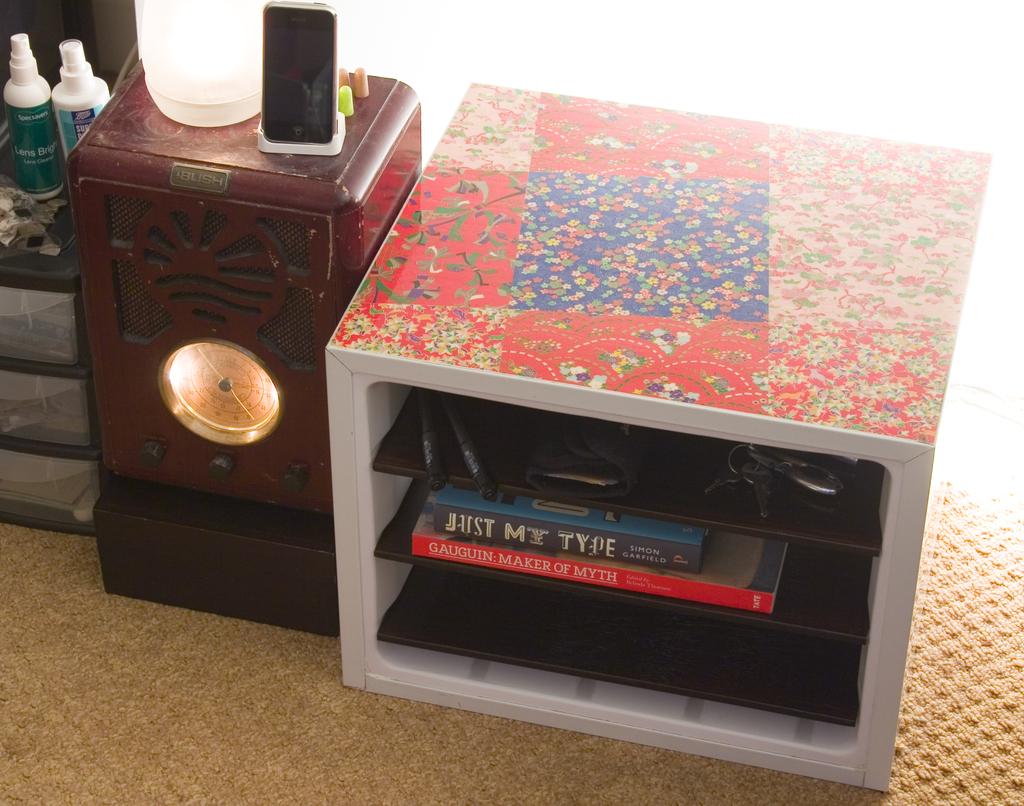How would you describe gauguin?
Make the answer very short. Unanswerable. What does the book on the very top say?
Your answer should be very brief. Just my type. 